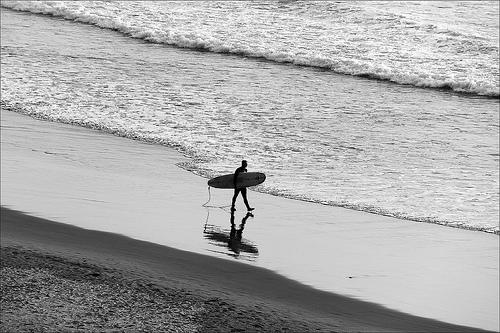Question: when was this?
Choices:
A. Daytime.
B. Nighttime sunset.
C. Dusk.
D. Dawn.
Answer with the letter. Answer: A Question: how is the photo?
Choices:
A. Grey.
B. Clear.
C. Spotty.
D. Jagged.
Answer with the letter. Answer: B Question: why is he standing?
Choices:
A. Waiting.
B. Lost.
C. To walk.
D. Tired.
Answer with the letter. Answer: C Question: where was this photo taken?
Choices:
A. On a beach.
B. By the river.
C. By the ocean.
D. In the village.
Answer with the letter. Answer: A 